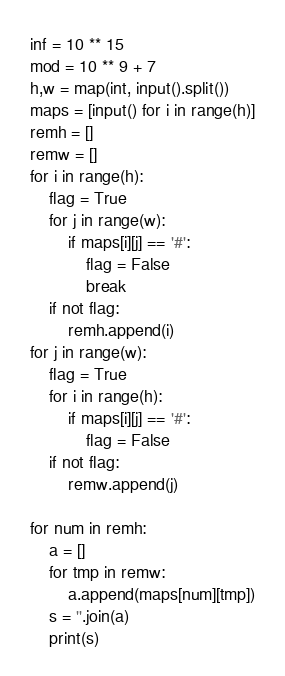Convert code to text. <code><loc_0><loc_0><loc_500><loc_500><_Python_>inf = 10 ** 15
mod = 10 ** 9 + 7
h,w = map(int, input().split())
maps = [input() for i in range(h)]
remh = []
remw = []
for i in range(h):
    flag = True
    for j in range(w):
        if maps[i][j] == '#':
            flag = False
            break
    if not flag:
        remh.append(i)
for j in range(w):
    flag = True
    for i in range(h):
        if maps[i][j] == '#':
            flag = False
    if not flag:
        remw.append(j)

for num in remh:
    a = []
    for tmp in remw:
        a.append(maps[num][tmp])
    s = ''.join(a)
    print(s)
</code> 